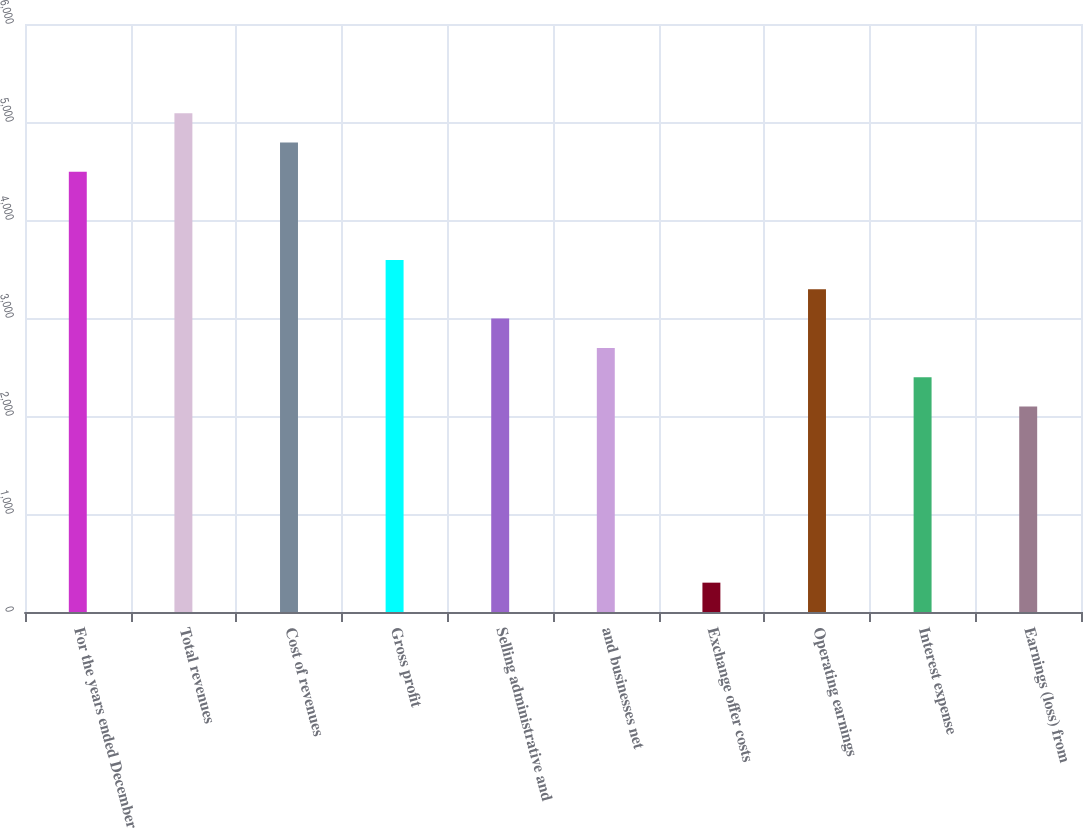Convert chart. <chart><loc_0><loc_0><loc_500><loc_500><bar_chart><fcel>For the years ended December<fcel>Total revenues<fcel>Cost of revenues<fcel>Gross profit<fcel>Selling administrative and<fcel>and businesses net<fcel>Exchange offer costs<fcel>Operating earnings<fcel>Interest expense<fcel>Earnings (loss) from<nl><fcel>4491.32<fcel>5090.16<fcel>4790.74<fcel>3593.06<fcel>2994.22<fcel>2694.8<fcel>299.44<fcel>3293.64<fcel>2395.38<fcel>2095.96<nl></chart> 